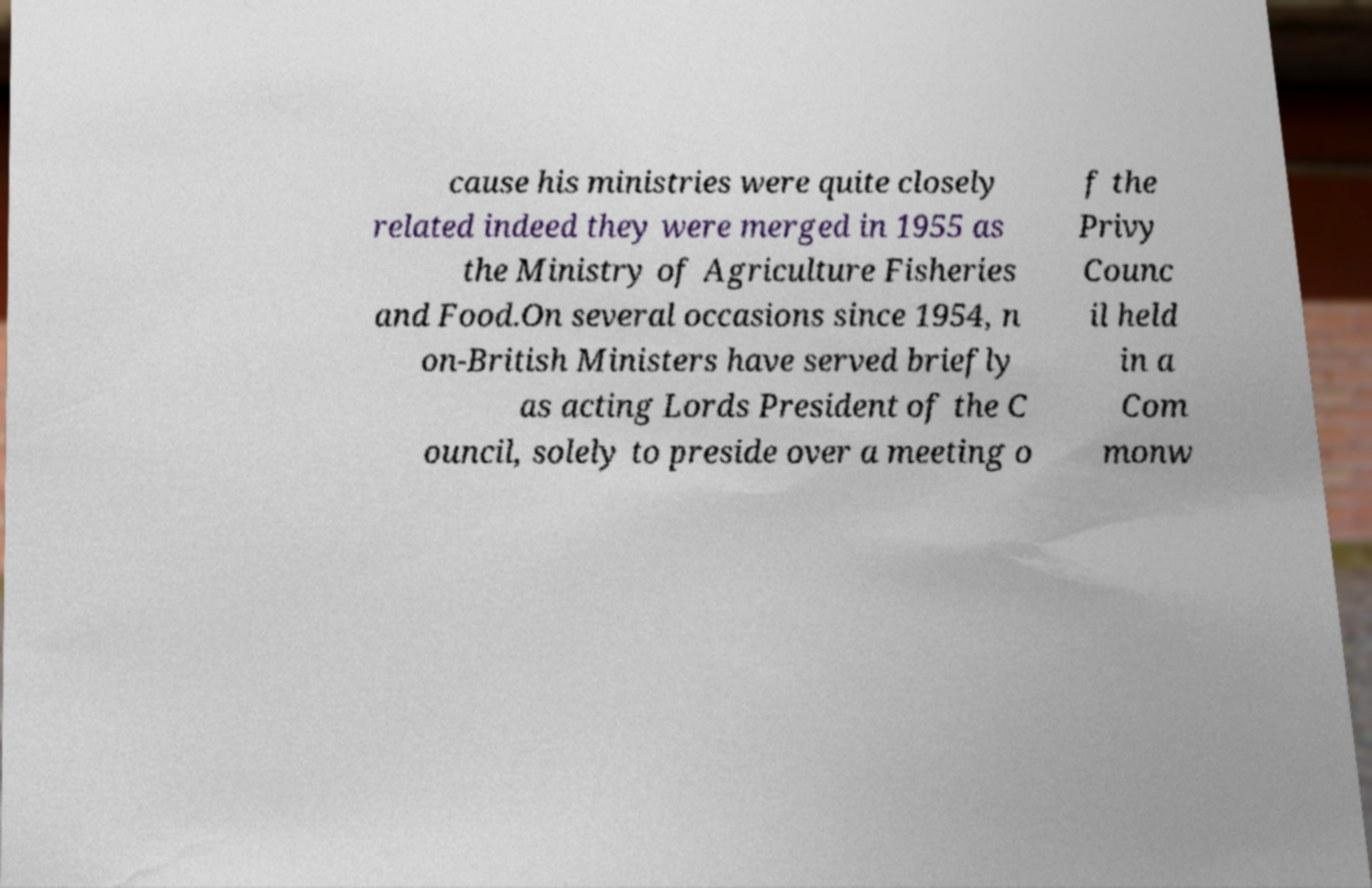Can you read and provide the text displayed in the image?This photo seems to have some interesting text. Can you extract and type it out for me? cause his ministries were quite closely related indeed they were merged in 1955 as the Ministry of Agriculture Fisheries and Food.On several occasions since 1954, n on-British Ministers have served briefly as acting Lords President of the C ouncil, solely to preside over a meeting o f the Privy Counc il held in a Com monw 